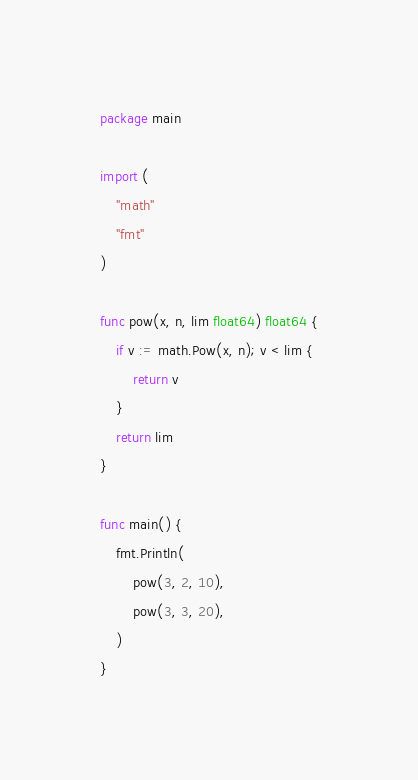Convert code to text. <code><loc_0><loc_0><loc_500><loc_500><_Go_>package main

import (
	"math"
	"fmt"
)

func pow(x, n, lim float64) float64 {
	if v := math.Pow(x, n); v < lim {
		return v
	}
	return lim
}

func main() {
	fmt.Println(
		pow(3, 2, 10),
		pow(3, 3, 20),
	)
}
</code> 